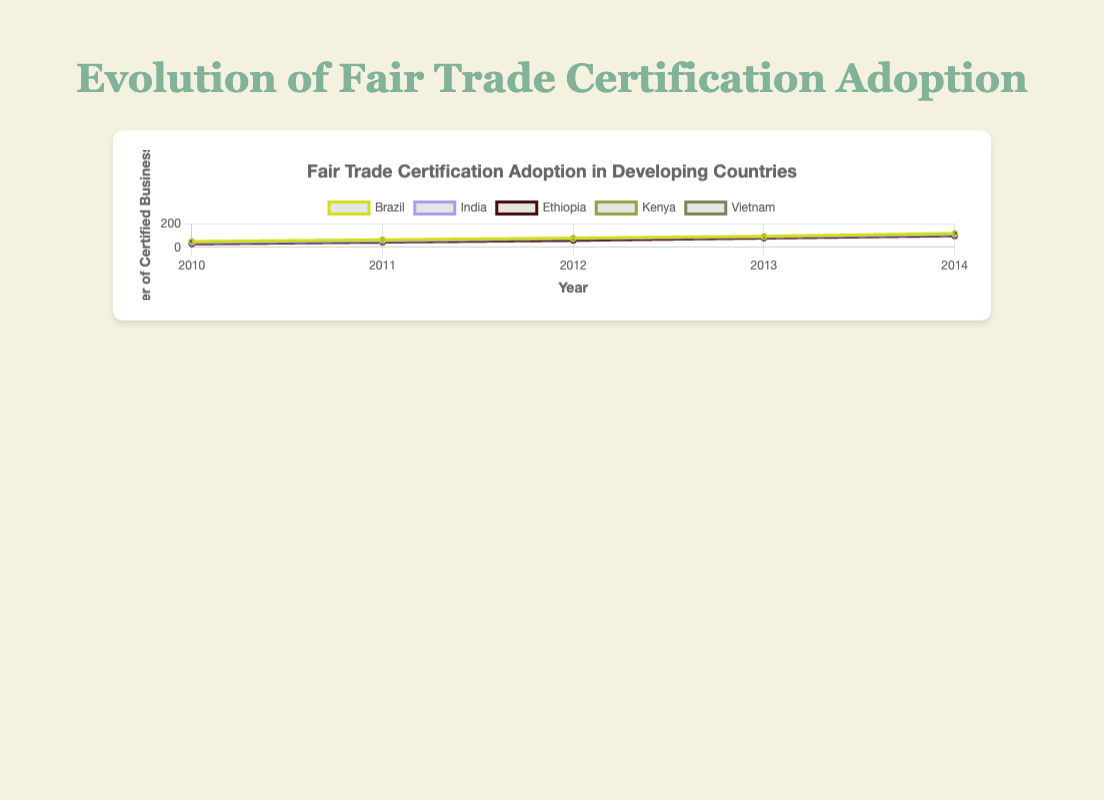Which country had the highest number of Fair Trade certified businesses in 2014? By looking at the end points of the lines for 2014, we can see that Brazil had the highest number with 120 certified businesses.
Answer: Brazil How did the number of certified businesses in Kenya change from 2010 to 2014? The line for Kenya starts at 35 in 2010 and ends at 105 in 2014. Calculating the difference, we get 105 - 35 = 70, so the number of certified businesses in Kenya increased by 70.
Answer: Increased by 70 Which country saw the largest increase in certified businesses between 2010 and 2014? By comparing the starting and ending points of each country's line, we see that Brazil increased from 50 to 120 (70 increase), India from 40 to 110 (70 increase), Ethiopia from 30 to 100 (70 increase), Kenya from 35 to 105 (70 increase), and Vietnam from 45 to 115 (70 increase). No single country had the largest increase; multiple countries were the same.
Answer: Brazil, India, Ethiopia, Kenya, and Vietnam (All had 70 increase) What is the average number of certified businesses across all countries in 2014? Sum the number of certified businesses for each country in 2014 (120 for Brazil, 110 for India, 100 for Ethiopia, 105 for Kenya, and 115 for Vietnam) which equals 550. The average is then 550 / 5 = 110.
Answer: 110 Between which years did Ethiopia see the greatest increase in certified businesses? By examining the points for Ethiopia, we see the increases are: 2010-2011: 15, 2011-2012: 15, 2012-2013: 20, 2013-2014: 20. The greatest increases are from 2012-2013 and 2013-2014 with 20 each.
Answer: 2012-2013 and 2013-2014 (both 20) In which year did Vietnam surpass Kenya in the number of certified businesses? Following the lines for Vietnam and Kenya, we see that in 2012 both countries had their lines cross. In 2013, Vietnam had more certified businesses (95) compared to Kenya (85).
Answer: 2012 What is the total increase in certified businesses for all countries combined from 2010 to 2014? For each country calculate 2014 minus 2010: Brazil: 70, India: 70, Ethiopia: 70, Kenya: 70, Vietnam: 70. Summing them gives 70 + 70 + 70 + 70 + 70 = 350.
Answer: 350 Which country had the steepest initial increase in certified businesses from 2010 to 2011? Comparing the differences from 2010 to 2011: Brazil increased by 15, India by 15, Ethiopia by 15, Kenya by 15, Vietnam by 15. All countries had the same initial increase.
Answer: Brazil, India, Ethiopia, Kenya, and Vietnam (All increased by 15) 